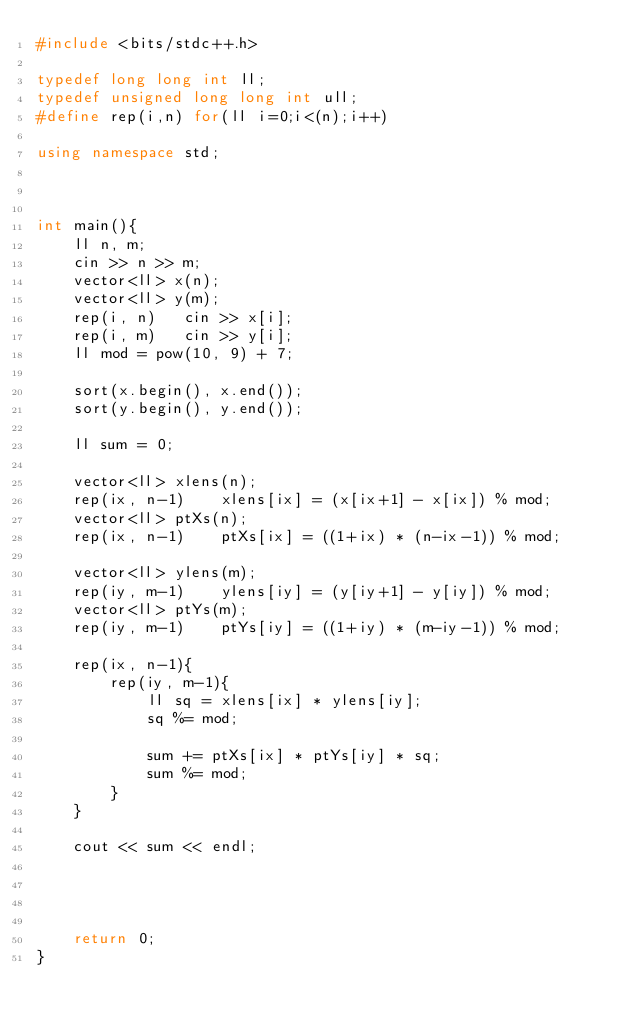<code> <loc_0><loc_0><loc_500><loc_500><_C++_>#include <bits/stdc++.h>

typedef long long int ll;
typedef unsigned long long int ull;
#define rep(i,n) for(ll i=0;i<(n);i++)

using namespace std;



int main(){
    ll n, m;
    cin >> n >> m;
    vector<ll> x(n);
    vector<ll> y(m);
    rep(i, n)   cin >> x[i];
    rep(i, m)   cin >> y[i];
    ll mod = pow(10, 9) + 7;

    sort(x.begin(), x.end());
    sort(y.begin(), y.end());

    ll sum = 0;

    vector<ll> xlens(n);
    rep(ix, n-1)    xlens[ix] = (x[ix+1] - x[ix]) % mod;
    vector<ll> ptXs(n);
    rep(ix, n-1)    ptXs[ix] = ((1+ix) * (n-ix-1)) % mod;

    vector<ll> ylens(m);
    rep(iy, m-1)    ylens[iy] = (y[iy+1] - y[iy]) % mod;
    vector<ll> ptYs(m);
    rep(iy, m-1)    ptYs[iy] = ((1+iy) * (m-iy-1)) % mod;

    rep(ix, n-1){
        rep(iy, m-1){
            ll sq = xlens[ix] * ylens[iy];
            sq %= mod;

            sum += ptXs[ix] * ptYs[iy] * sq;
            sum %= mod;
        }
    }

    cout << sum << endl;

    


    return 0;
}
</code> 